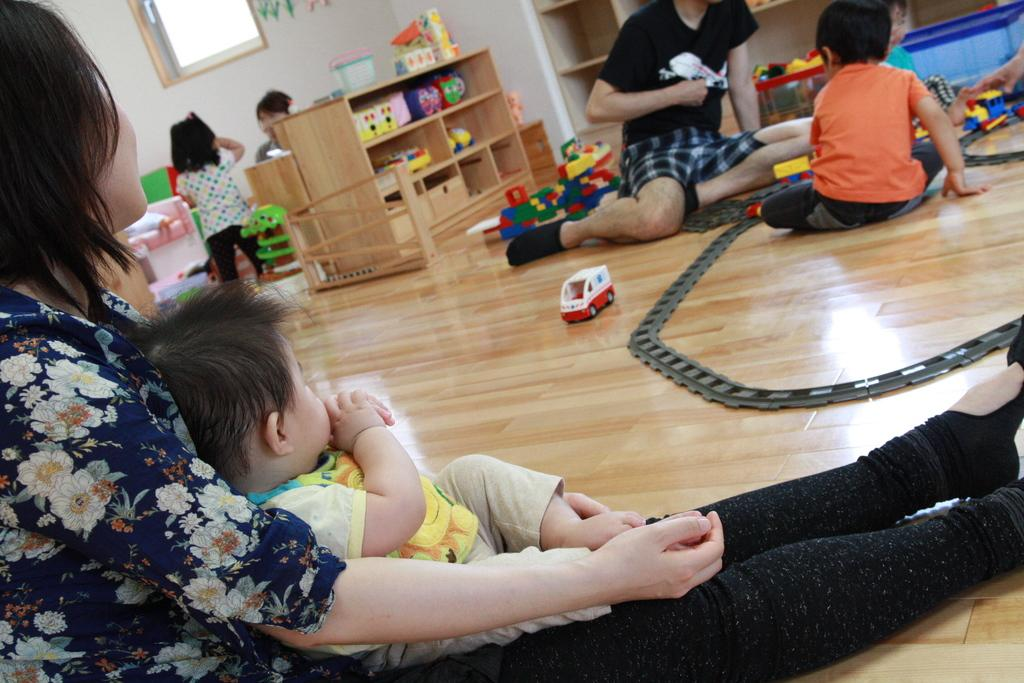Who is present in the image? There are elders and children in the image. What are the elders and children doing in the image? The elders and children are sitting on the floor. What can be seen on the floor with the elders and children? There are toys in the image. Where are more toys located in the image? There is a wooden shelf with other toys in the image. What is visible on the wall in the image? There is a window on the wall in the image. How many spiders are crawling on the wooden shelf in the image? There are no spiders visible on the wooden shelf in the image. What is the opinion of the elders about the stem of the toy plant in the image? There is no toy plant or any indication of the elders' opinions about stems in the image. 